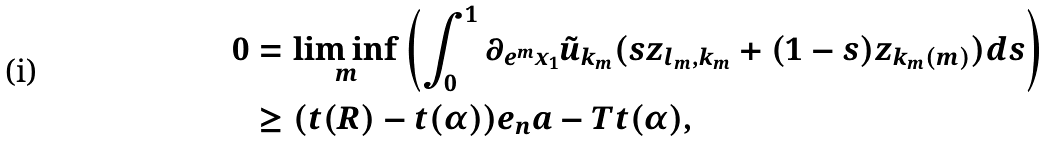Convert formula to latex. <formula><loc_0><loc_0><loc_500><loc_500>0 & = \liminf _ { m } \left ( \int _ { 0 } ^ { 1 } \partial _ { e ^ { m } x _ { 1 } } \tilde { u } _ { k _ { m } } ( s z _ { l _ { m } , k _ { m } } + ( 1 - s ) z _ { k _ { m } ( m ) } ) d s \right ) \\ & \geq ( t ( R ) - t ( \alpha ) ) e _ { n } a - T t ( \alpha ) ,</formula> 